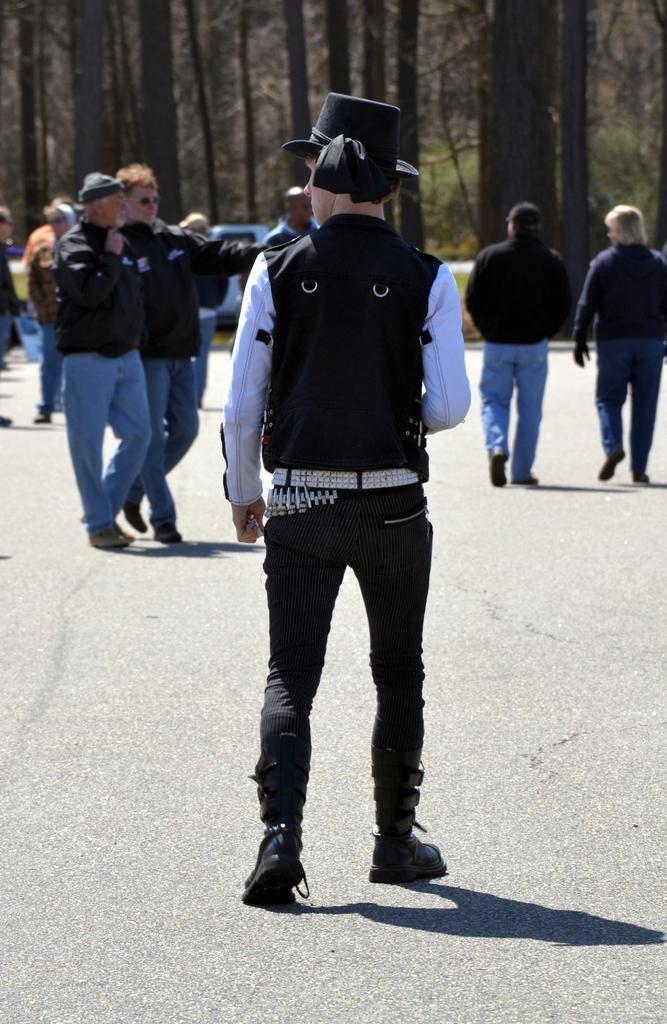In one or two sentences, can you explain what this image depicts? In front of the picture, we see a man in the white shirt who is wearing a black jacket and a black hat is standing. At the bottom, we see the road. In front of him, we see the people are standing. On the right side, we see two people are walking on the road. In the background, we see a white vehicle and the trees. 